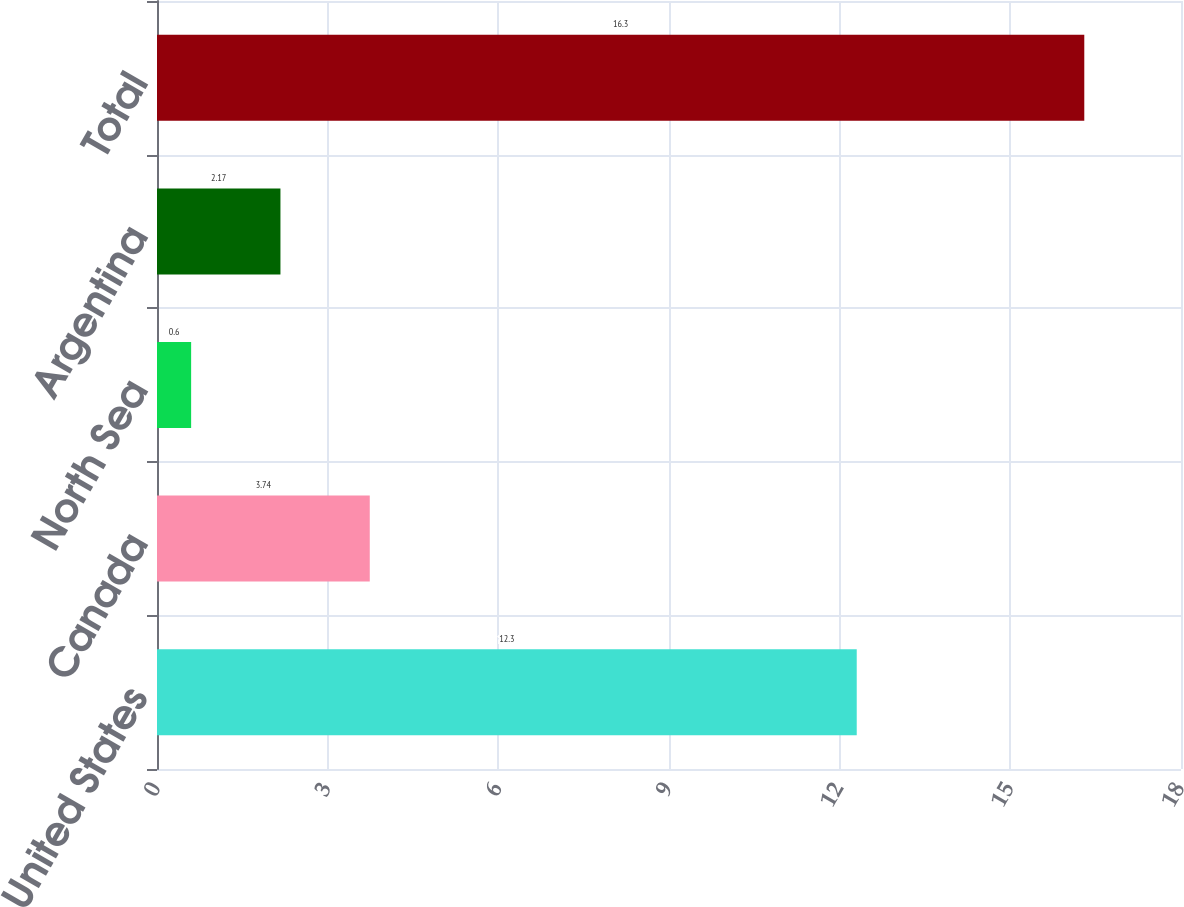<chart> <loc_0><loc_0><loc_500><loc_500><bar_chart><fcel>United States<fcel>Canada<fcel>North Sea<fcel>Argentina<fcel>Total<nl><fcel>12.3<fcel>3.74<fcel>0.6<fcel>2.17<fcel>16.3<nl></chart> 